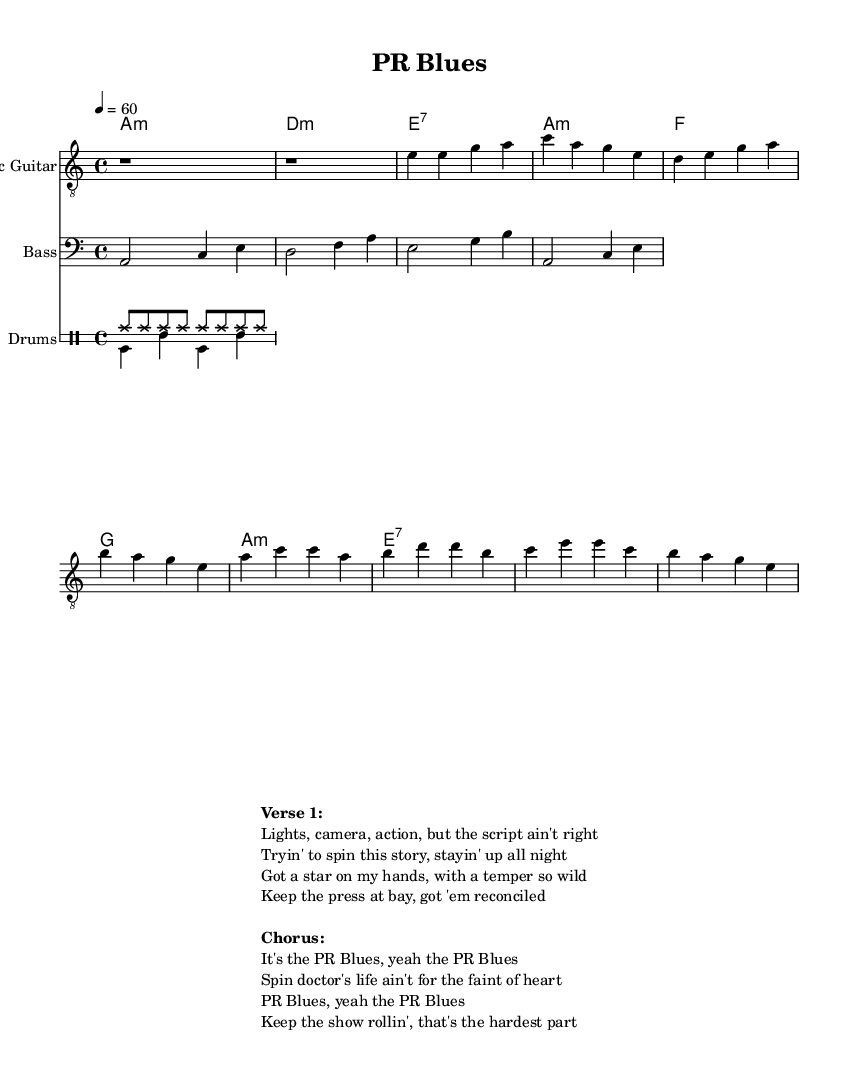What is the key signature of this music? The key signature shows one flat, indicating that the piece is in A minor, which is the relative minor of C major.
Answer: A minor What is the time signature of this music? The time signature is located at the beginning of the sheet music, showing 4/4, which means there are four beats in every measure and the quarter note gets one beat.
Answer: 4/4 What is the tempo marking of this music? The tempo marking is indicated at the start and is set to 60 beats per minute, meaning the piece is played slowly, resembling a ballad feel.
Answer: 60 How many measures are in the verse section? By counting the measures between the introduction and the chorus, we see there are four measures in the verse.
Answer: 4 What chord follows the D minor chord in the verse? The chord progression shows D minor is followed by E7 in the next measure.
Answer: E7 What type of emotional theme is expressed in the lyrics? The lyrics articulate the struggles and emotional challenges faced in PR campaigns within the entertainment industry, highlighting themes of pressure and resilience.
Answer: Struggles What is the main subject of the chorus? The chorus discusses the challenges of being a PR professional, emphasizing the difficulties and pressures inherent in that role.
Answer: PR challenges 